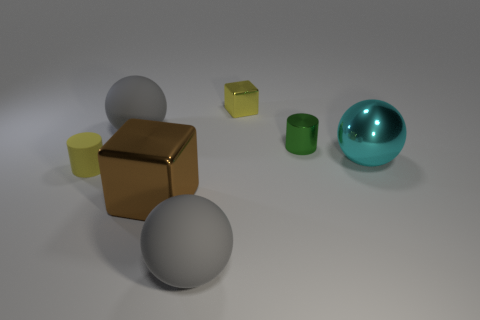Subtract all matte balls. How many balls are left? 1 Subtract all red cubes. How many gray balls are left? 2 Add 1 brown cubes. How many objects exist? 8 Subtract all purple spheres. Subtract all gray cubes. How many spheres are left? 3 Subtract 0 gray cylinders. How many objects are left? 7 Subtract all cylinders. How many objects are left? 5 Subtract all big brown blocks. Subtract all metallic things. How many objects are left? 2 Add 6 tiny rubber cylinders. How many tiny rubber cylinders are left? 7 Add 7 big metal objects. How many big metal objects exist? 9 